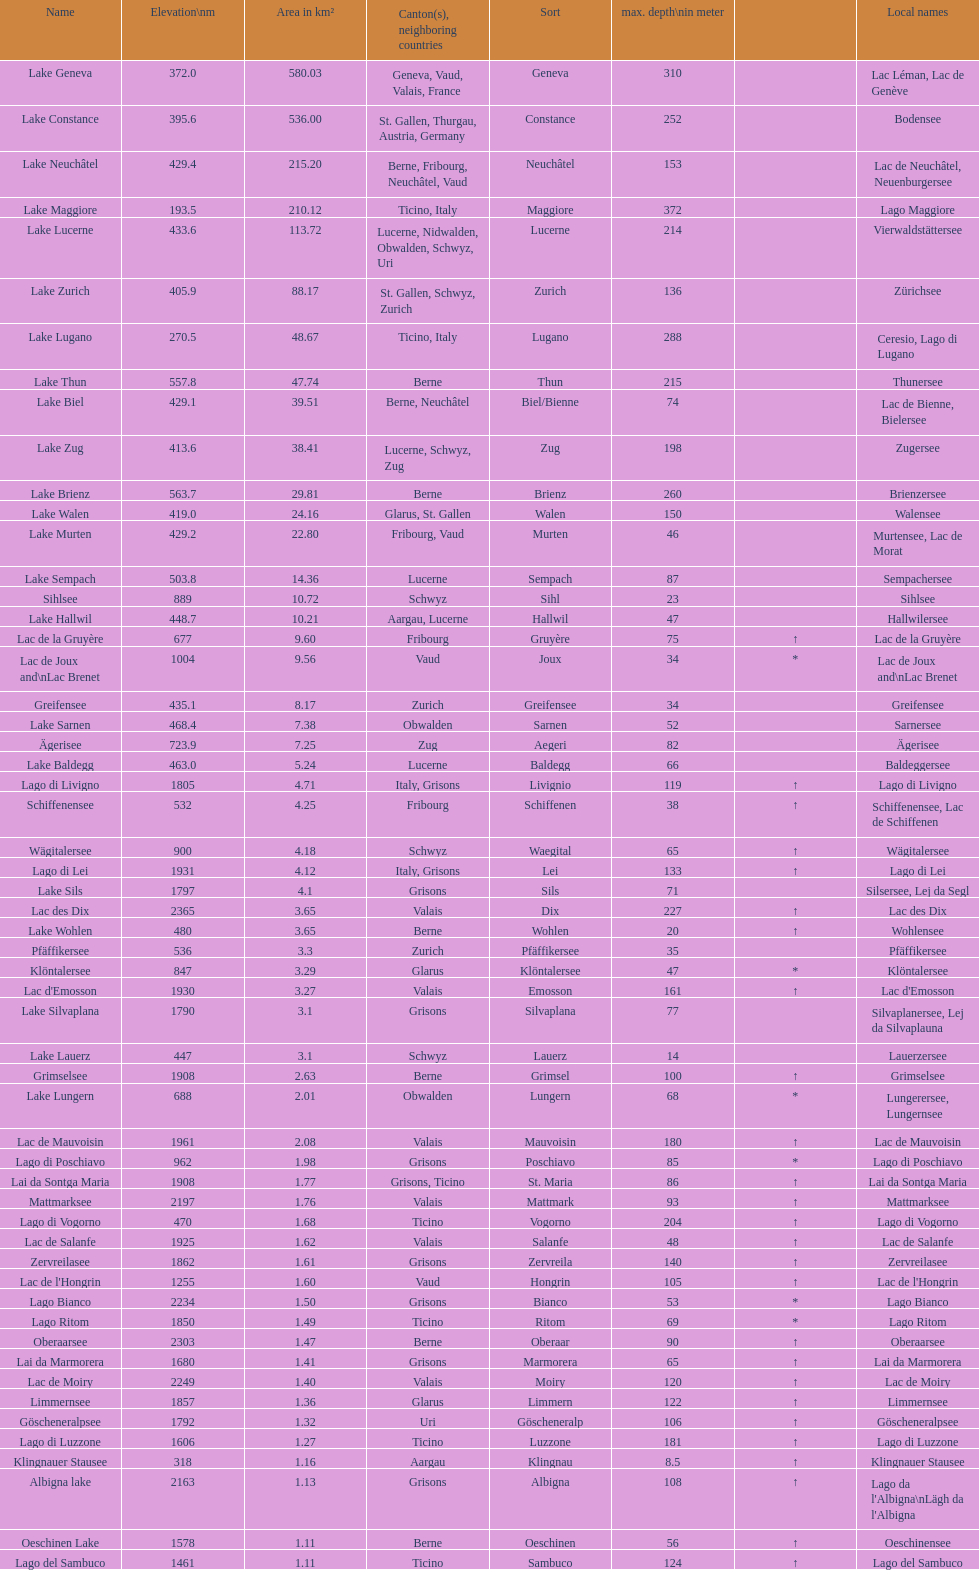Would you be able to parse every entry in this table? {'header': ['Name', 'Elevation\\nm', 'Area in km²', 'Canton(s), neighboring countries', 'Sort', 'max. depth\\nin meter', '', 'Local names'], 'rows': [['Lake Geneva', '372.0', '580.03', 'Geneva, Vaud, Valais, France', 'Geneva', '310', '', 'Lac Léman, Lac de Genève'], ['Lake Constance', '395.6', '536.00', 'St. Gallen, Thurgau, Austria, Germany', 'Constance', '252', '', 'Bodensee'], ['Lake Neuchâtel', '429.4', '215.20', 'Berne, Fribourg, Neuchâtel, Vaud', 'Neuchâtel', '153', '', 'Lac de Neuchâtel, Neuenburgersee'], ['Lake Maggiore', '193.5', '210.12', 'Ticino, Italy', 'Maggiore', '372', '', 'Lago Maggiore'], ['Lake Lucerne', '433.6', '113.72', 'Lucerne, Nidwalden, Obwalden, Schwyz, Uri', 'Lucerne', '214', '', 'Vierwaldstättersee'], ['Lake Zurich', '405.9', '88.17', 'St. Gallen, Schwyz, Zurich', 'Zurich', '136', '', 'Zürichsee'], ['Lake Lugano', '270.5', '48.67', 'Ticino, Italy', 'Lugano', '288', '', 'Ceresio, Lago di Lugano'], ['Lake Thun', '557.8', '47.74', 'Berne', 'Thun', '215', '', 'Thunersee'], ['Lake Biel', '429.1', '39.51', 'Berne, Neuchâtel', 'Biel/Bienne', '74', '', 'Lac de Bienne, Bielersee'], ['Lake Zug', '413.6', '38.41', 'Lucerne, Schwyz, Zug', 'Zug', '198', '', 'Zugersee'], ['Lake Brienz', '563.7', '29.81', 'Berne', 'Brienz', '260', '', 'Brienzersee'], ['Lake Walen', '419.0', '24.16', 'Glarus, St. Gallen', 'Walen', '150', '', 'Walensee'], ['Lake Murten', '429.2', '22.80', 'Fribourg, Vaud', 'Murten', '46', '', 'Murtensee, Lac de Morat'], ['Lake Sempach', '503.8', '14.36', 'Lucerne', 'Sempach', '87', '', 'Sempachersee'], ['Sihlsee', '889', '10.72', 'Schwyz', 'Sihl', '23', '', 'Sihlsee'], ['Lake Hallwil', '448.7', '10.21', 'Aargau, Lucerne', 'Hallwil', '47', '', 'Hallwilersee'], ['Lac de la Gruyère', '677', '9.60', 'Fribourg', 'Gruyère', '75', '↑', 'Lac de la Gruyère'], ['Lac de Joux and\\nLac Brenet', '1004', '9.56', 'Vaud', 'Joux', '34', '*', 'Lac de Joux and\\nLac Brenet'], ['Greifensee', '435.1', '8.17', 'Zurich', 'Greifensee', '34', '', 'Greifensee'], ['Lake Sarnen', '468.4', '7.38', 'Obwalden', 'Sarnen', '52', '', 'Sarnersee'], ['Ägerisee', '723.9', '7.25', 'Zug', 'Aegeri', '82', '', 'Ägerisee'], ['Lake Baldegg', '463.0', '5.24', 'Lucerne', 'Baldegg', '66', '', 'Baldeggersee'], ['Lago di Livigno', '1805', '4.71', 'Italy, Grisons', 'Livignio', '119', '↑', 'Lago di Livigno'], ['Schiffenensee', '532', '4.25', 'Fribourg', 'Schiffenen', '38', '↑', 'Schiffenensee, Lac de Schiffenen'], ['Wägitalersee', '900', '4.18', 'Schwyz', 'Waegital', '65', '↑', 'Wägitalersee'], ['Lago di Lei', '1931', '4.12', 'Italy, Grisons', 'Lei', '133', '↑', 'Lago di Lei'], ['Lake Sils', '1797', '4.1', 'Grisons', 'Sils', '71', '', 'Silsersee, Lej da Segl'], ['Lac des Dix', '2365', '3.65', 'Valais', 'Dix', '227', '↑', 'Lac des Dix'], ['Lake Wohlen', '480', '3.65', 'Berne', 'Wohlen', '20', '↑', 'Wohlensee'], ['Pfäffikersee', '536', '3.3', 'Zurich', 'Pfäffikersee', '35', '', 'Pfäffikersee'], ['Klöntalersee', '847', '3.29', 'Glarus', 'Klöntalersee', '47', '*', 'Klöntalersee'], ["Lac d'Emosson", '1930', '3.27', 'Valais', 'Emosson', '161', '↑', "Lac d'Emosson"], ['Lake Silvaplana', '1790', '3.1', 'Grisons', 'Silvaplana', '77', '', 'Silvaplanersee, Lej da Silvaplauna'], ['Lake Lauerz', '447', '3.1', 'Schwyz', 'Lauerz', '14', '', 'Lauerzersee'], ['Grimselsee', '1908', '2.63', 'Berne', 'Grimsel', '100', '↑', 'Grimselsee'], ['Lake Lungern', '688', '2.01', 'Obwalden', 'Lungern', '68', '*', 'Lungerersee, Lungernsee'], ['Lac de Mauvoisin', '1961', '2.08', 'Valais', 'Mauvoisin', '180', '↑', 'Lac de Mauvoisin'], ['Lago di Poschiavo', '962', '1.98', 'Grisons', 'Poschiavo', '85', '*', 'Lago di Poschiavo'], ['Lai da Sontga Maria', '1908', '1.77', 'Grisons, Ticino', 'St. Maria', '86', '↑', 'Lai da Sontga Maria'], ['Mattmarksee', '2197', '1.76', 'Valais', 'Mattmark', '93', '↑', 'Mattmarksee'], ['Lago di Vogorno', '470', '1.68', 'Ticino', 'Vogorno', '204', '↑', 'Lago di Vogorno'], ['Lac de Salanfe', '1925', '1.62', 'Valais', 'Salanfe', '48', '↑', 'Lac de Salanfe'], ['Zervreilasee', '1862', '1.61', 'Grisons', 'Zervreila', '140', '↑', 'Zervreilasee'], ["Lac de l'Hongrin", '1255', '1.60', 'Vaud', 'Hongrin', '105', '↑', "Lac de l'Hongrin"], ['Lago Bianco', '2234', '1.50', 'Grisons', 'Bianco', '53', '*', 'Lago Bianco'], ['Lago Ritom', '1850', '1.49', 'Ticino', 'Ritom', '69', '*', 'Lago Ritom'], ['Oberaarsee', '2303', '1.47', 'Berne', 'Oberaar', '90', '↑', 'Oberaarsee'], ['Lai da Marmorera', '1680', '1.41', 'Grisons', 'Marmorera', '65', '↑', 'Lai da Marmorera'], ['Lac de Moiry', '2249', '1.40', 'Valais', 'Moiry', '120', '↑', 'Lac de Moiry'], ['Limmernsee', '1857', '1.36', 'Glarus', 'Limmern', '122', '↑', 'Limmernsee'], ['Göscheneralpsee', '1792', '1.32', 'Uri', 'Göscheneralp', '106', '↑', 'Göscheneralpsee'], ['Lago di Luzzone', '1606', '1.27', 'Ticino', 'Luzzone', '181', '↑', 'Lago di Luzzone'], ['Klingnauer Stausee', '318', '1.16', 'Aargau', 'Klingnau', '8.5', '↑', 'Klingnauer Stausee'], ['Albigna lake', '2163', '1.13', 'Grisons', 'Albigna', '108', '↑', "Lago da l'Albigna\\nLägh da l'Albigna"], ['Oeschinen Lake', '1578', '1.11', 'Berne', 'Oeschinen', '56', '↑', 'Oeschinensee'], ['Lago del Sambuco', '1461', '1.11', 'Ticino', 'Sambuco', '124', '↑', 'Lago del Sambuco']]} What is the combined total depth of the three deepest lakes? 970. 